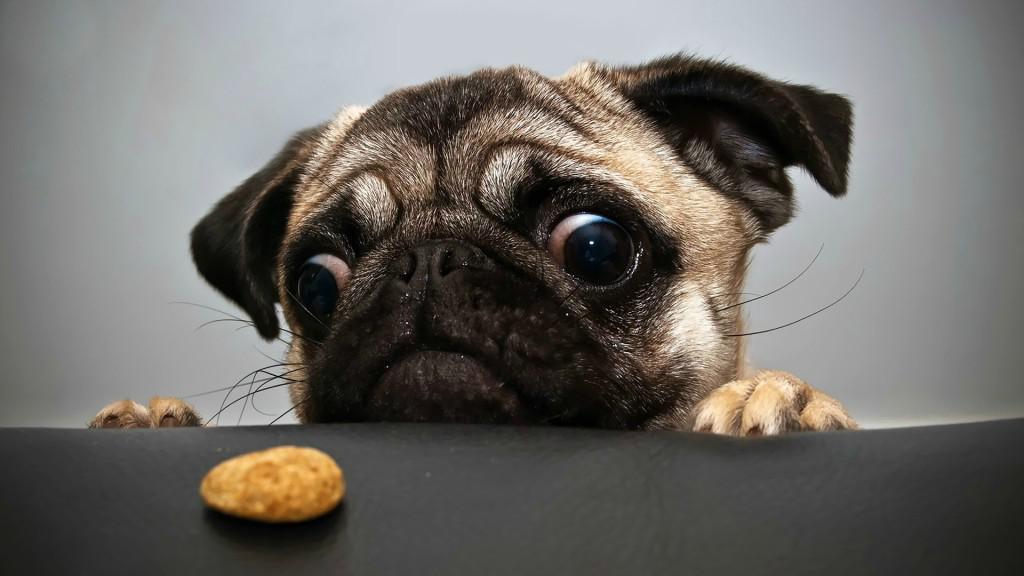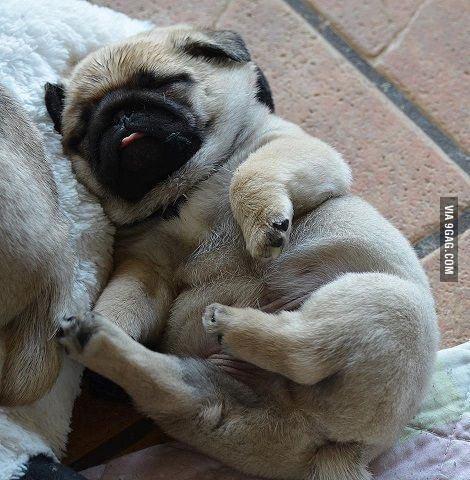The first image is the image on the left, the second image is the image on the right. For the images displayed, is the sentence "In one of the images there is one dog and one round silver dog food dish." factually correct? Answer yes or no. No. The first image is the image on the left, the second image is the image on the right. Examine the images to the left and right. Is the description "One dog is standing with his face bent down in a bowl, and the other dog is looking at the camera." accurate? Answer yes or no. No. 